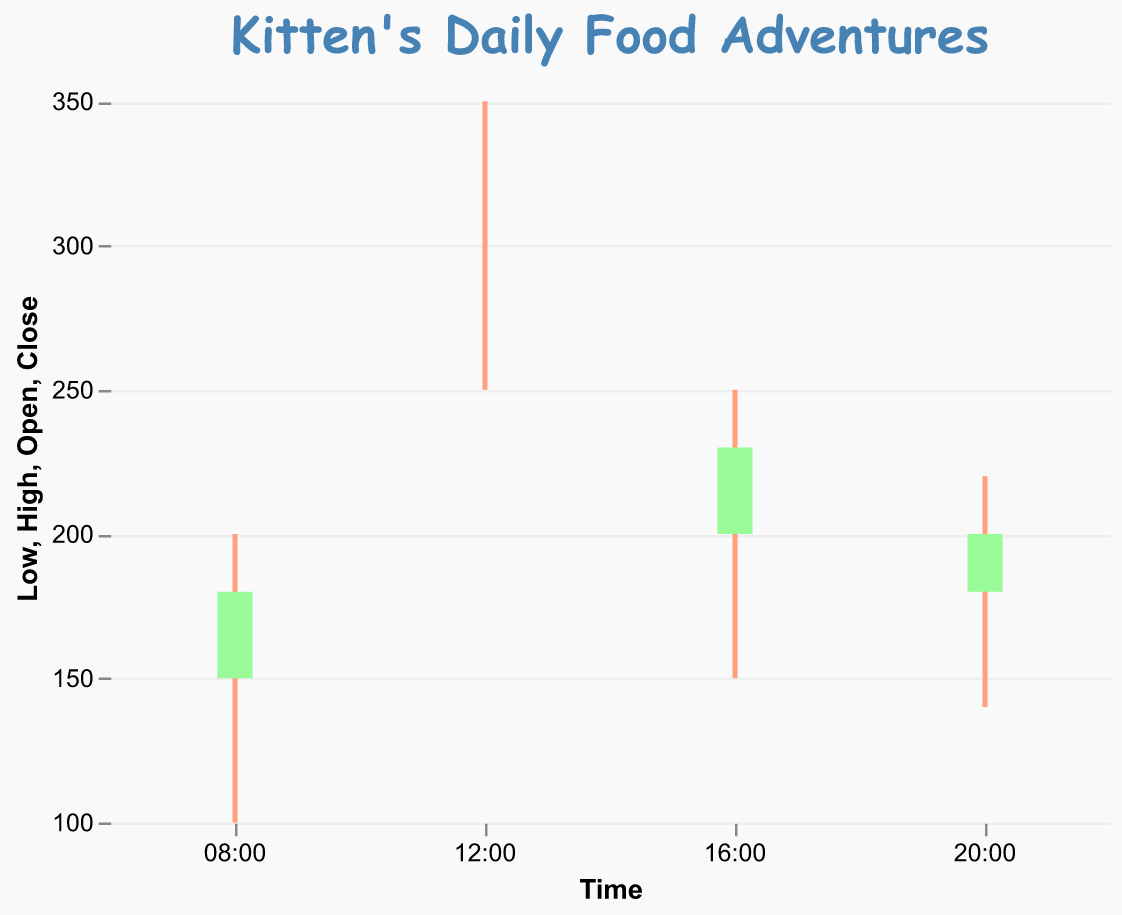What's the title of the candlestick chart? The title is usually at the top of the chart and visually stands out. By looking at the chart, you can find the text element that serves as the title.
Answer: Kitten's Daily Food Adventures At which time was the highest food consumption recorded? The highest food consumption corresponds to the highest "High" value on the y-axis for a specific time on the x-axis. Looking at the chart, the "High" value is the top end of the vertical line for each time period. The highest is recorded at 12:00.
Answer: 12:00 How did the food consumption change from 08:00 to 12:00? To see the change between these two times, compare the "Close" value at 08:00 with the "Open" value at 12:00. The "Close" at 08:00 is 180, and the "Open" at 12:00 is 300. This indicates an increase.
Answer: Increased Which time period had the least variation in food consumption? Variation in food consumption can be evaluated by the length of the vertical line (High-Low). Shorter lines indicate less variation. Look at each vertical line and find the smallest. From the chart, 20:00 has the smallest variation (220-140=80).
Answer: 20:00 Was the food consumption higher at the end of the day compared to the beginning? Compare the "Close" value at 20:00 with the "Open" value at 08:00. The "Close" at 20:00 is 200, and the "Open" at 08:00 is 150. The food consumption was higher at the end of the day.
Answer: Yes Which time period had a downward trend in food consumption? A downward trend occurs if the "Close" value is less than the "Open" value. Checking all periods: at 08:00 (Close>Open), 12:00 (Close=Open), 16:00 (Close>Open), and at 20:00 (Close>Open). None had a downward trend.
Answer: None What is the average "High" value for the day? To find the average, sum all "High" values and divide by the number of periods. The High values are 200, 350, 250, and 220. (200 + 350 + 250 + 220)/4 = 1020/4 = 255.
Answer: 255 What time period had the second highest peak in food consumption? The peak is the "High" value for each period. The highest peak is at 12:00 (350). The second highest is at 16:00 (250).
Answer: 16:00 